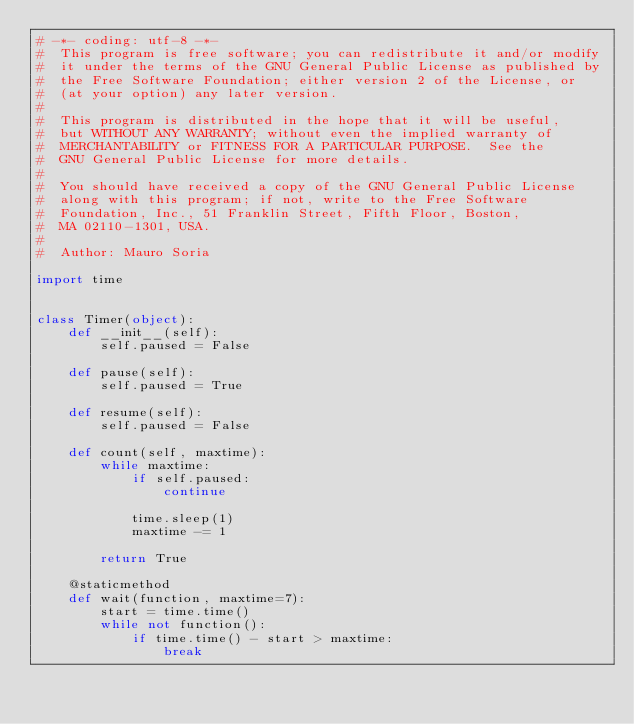<code> <loc_0><loc_0><loc_500><loc_500><_Python_># -*- coding: utf-8 -*-
#  This program is free software; you can redistribute it and/or modify
#  it under the terms of the GNU General Public License as published by
#  the Free Software Foundation; either version 2 of the License, or
#  (at your option) any later version.
#
#  This program is distributed in the hope that it will be useful,
#  but WITHOUT ANY WARRANTY; without even the implied warranty of
#  MERCHANTABILITY or FITNESS FOR A PARTICULAR PURPOSE.  See the
#  GNU General Public License for more details.
#
#  You should have received a copy of the GNU General Public License
#  along with this program; if not, write to the Free Software
#  Foundation, Inc., 51 Franklin Street, Fifth Floor, Boston,
#  MA 02110-1301, USA.
#
#  Author: Mauro Soria

import time


class Timer(object):
    def __init__(self):
        self.paused = False

    def pause(self):
        self.paused = True

    def resume(self):
        self.paused = False

    def count(self, maxtime):
        while maxtime:
            if self.paused:
                continue

            time.sleep(1)
            maxtime -= 1

        return True

    @staticmethod
    def wait(function, maxtime=7):
        start = time.time()
        while not function():
            if time.time() - start > maxtime:
                break
</code> 